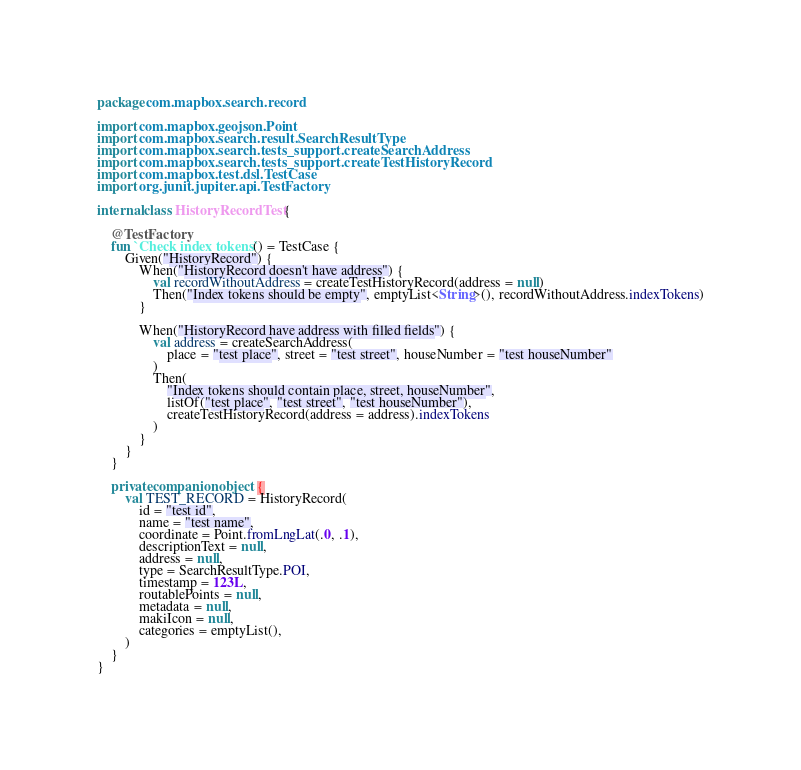<code> <loc_0><loc_0><loc_500><loc_500><_Kotlin_>package com.mapbox.search.record

import com.mapbox.geojson.Point
import com.mapbox.search.result.SearchResultType
import com.mapbox.search.tests_support.createSearchAddress
import com.mapbox.search.tests_support.createTestHistoryRecord
import com.mapbox.test.dsl.TestCase
import org.junit.jupiter.api.TestFactory

internal class HistoryRecordTest {

    @TestFactory
    fun `Check index tokens`() = TestCase {
        Given("HistoryRecord") {
            When("HistoryRecord doesn't have address") {
                val recordWithoutAddress = createTestHistoryRecord(address = null)
                Then("Index tokens should be empty", emptyList<String>(), recordWithoutAddress.indexTokens)
            }

            When("HistoryRecord have address with filled fields") {
                val address = createSearchAddress(
                    place = "test place", street = "test street", houseNumber = "test houseNumber"
                )
                Then(
                    "Index tokens should contain place, street, houseNumber",
                    listOf("test place", "test street", "test houseNumber"),
                    createTestHistoryRecord(address = address).indexTokens
                )
            }
        }
    }

    private companion object {
        val TEST_RECORD = HistoryRecord(
            id = "test id",
            name = "test name",
            coordinate = Point.fromLngLat(.0, .1),
            descriptionText = null,
            address = null,
            type = SearchResultType.POI,
            timestamp = 123L,
            routablePoints = null,
            metadata = null,
            makiIcon = null,
            categories = emptyList(),
        )
    }
}
</code> 